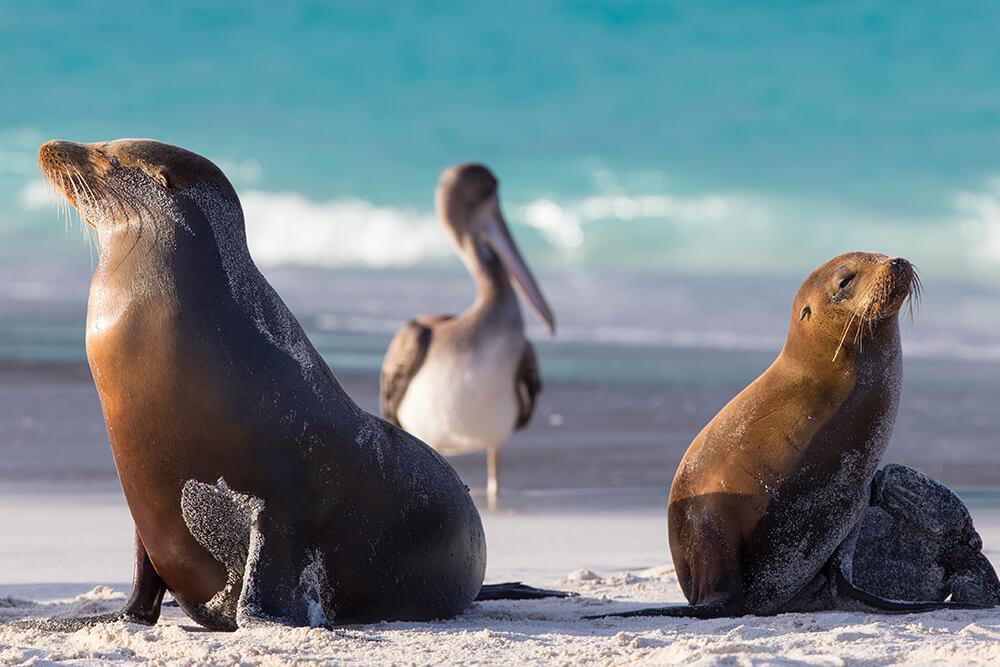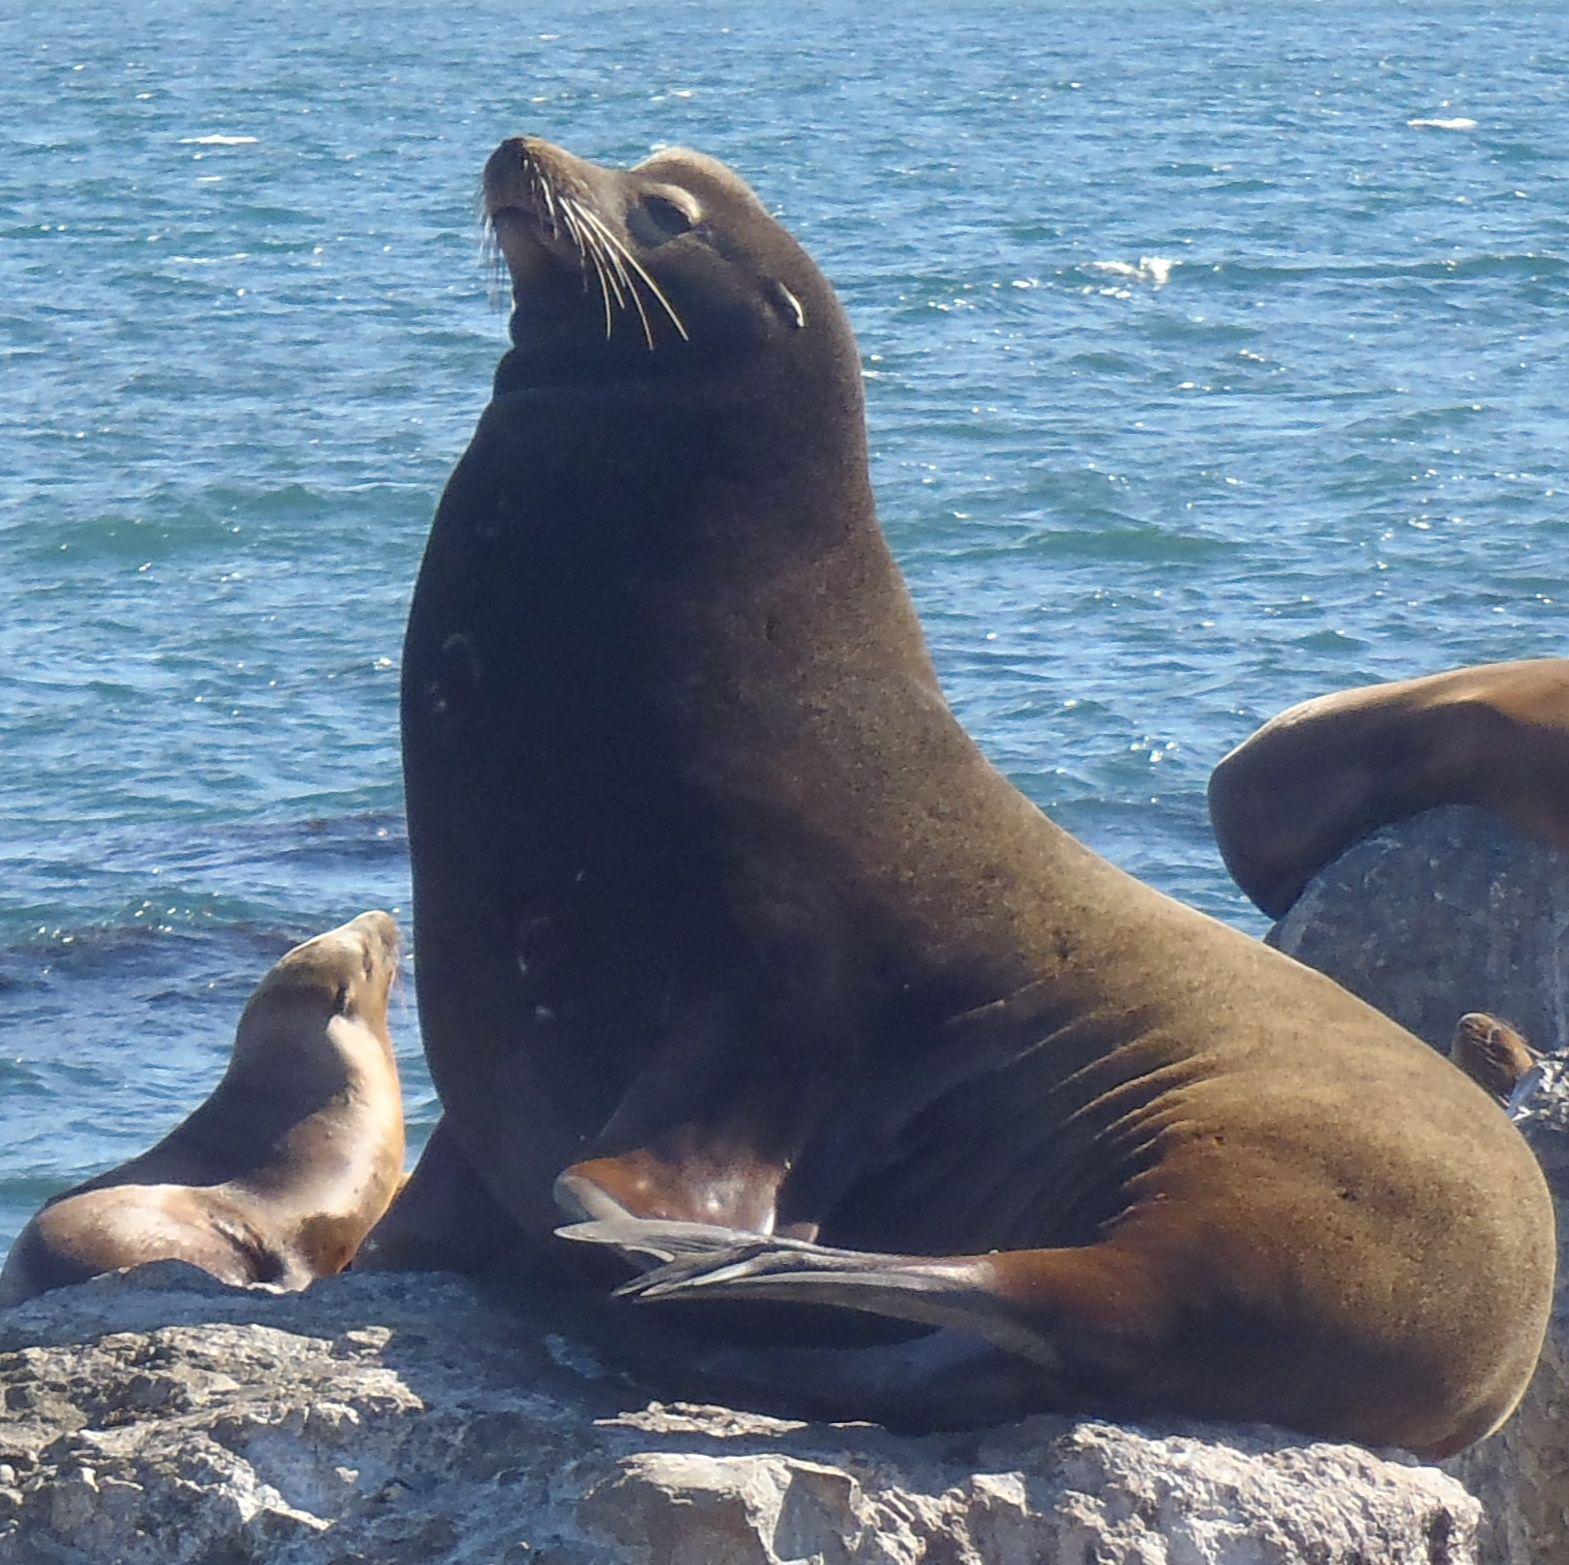The first image is the image on the left, the second image is the image on the right. For the images shown, is this caption "There is a bird in the image on the left." true? Answer yes or no. Yes. The first image is the image on the left, the second image is the image on the right. Given the left and right images, does the statement "Right image shows a seal on rocks in the center with a smaller animal to the left." hold true? Answer yes or no. Yes. 